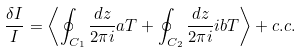<formula> <loc_0><loc_0><loc_500><loc_500>\frac { \delta I } { I } = \left \langle \oint _ { C _ { 1 } } \frac { d z } { 2 \pi i } a T + \oint _ { C _ { 2 } } \frac { d z } { 2 \pi i } i b T \right \rangle + c . c .</formula> 